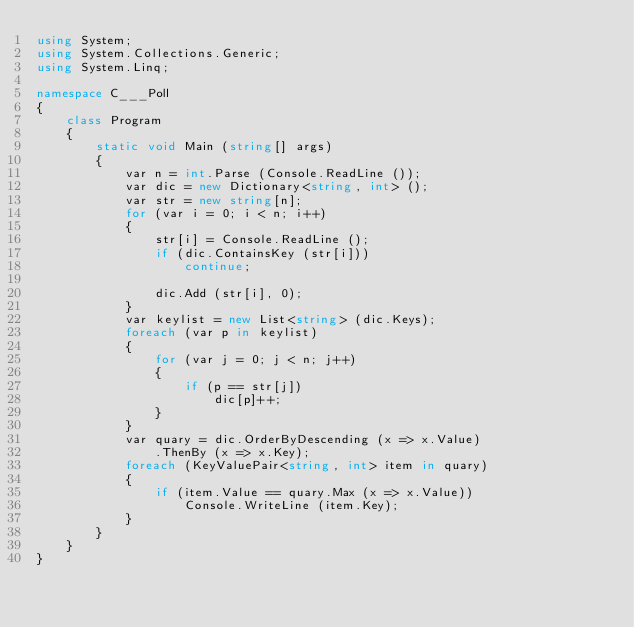<code> <loc_0><loc_0><loc_500><loc_500><_C#_>using System;
using System.Collections.Generic;
using System.Linq;

namespace C___Poll
{
    class Program
    {
        static void Main (string[] args)
        {
            var n = int.Parse (Console.ReadLine ());
            var dic = new Dictionary<string, int> ();
            var str = new string[n];
            for (var i = 0; i < n; i++)
            {
                str[i] = Console.ReadLine ();
                if (dic.ContainsKey (str[i]))
                    continue;

                dic.Add (str[i], 0);
            }
            var keylist = new List<string> (dic.Keys);
            foreach (var p in keylist)
            {
                for (var j = 0; j < n; j++)
                {
                    if (p == str[j])
                        dic[p]++;
                }
            }
            var quary = dic.OrderByDescending (x => x.Value)
                .ThenBy (x => x.Key);
            foreach (KeyValuePair<string, int> item in quary)
            {
                if (item.Value == quary.Max (x => x.Value))
                    Console.WriteLine (item.Key);
            }
        }
    }
}</code> 